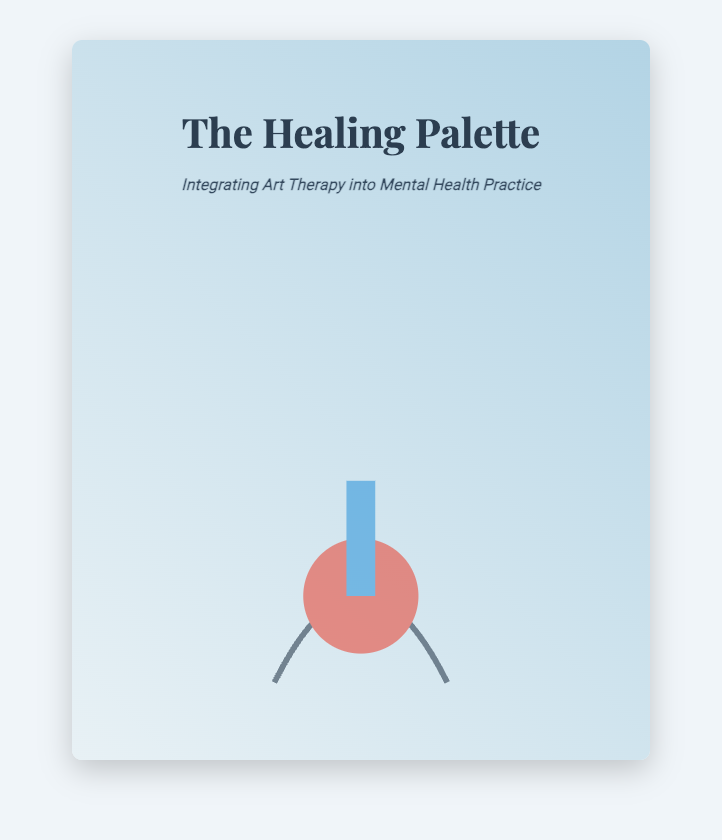what is the title of the book? The title of the book is prominently displayed at the top of the document, which is "The Healing Palette."
Answer: The Healing Palette who is the author of the book? The author's name is presented at the bottom of the document, which is "Dr. Jane Smith."
Answer: Dr. Jane Smith what is the subtitle of the book? The subtitle appears just below the title and describes the main focus, which is "Integrating Art Therapy into Mental Health Practice."
Answer: Integrating Art Therapy into Mental Health Practice how many colors are used in the background gradient? The background gradient consists of two colors: a light shade and a darker shade blending together.
Answer: Two what visual elements are included in the cover design? The cover features a paintbrush and palette as the central visual elements, contributing to the theme of creativity.
Answer: Paintbrush and palette what is the dominant theme reflected in the book cover? The serene watercolor backdrop along with other design elements highlights the theme of creativity and calmness related to art therapy.
Answer: Creativity and calmness what is the font style used for the book title? The font style for the title is "Playfair Display," which conveys elegance and creativity.
Answer: Playfair Display where is the visual element positioned on the cover? The visual element is placed at the bottom of the cover, central to the overall design.
Answer: Bottom center what is the main purpose of the book as suggested by the subtitle? The subtitle indicates the book's main purpose, which is to provide guidance on the integration of art therapy into mental health practice.
Answer: Guidance on integration of art therapy 